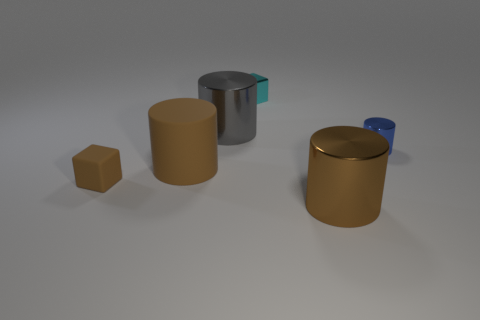Are there any other things that are the same material as the tiny brown thing?
Offer a very short reply. Yes. Does the large matte cylinder have the same color as the small block that is behind the gray cylinder?
Keep it short and to the point. No. There is a big metallic object in front of the cube in front of the blue metal cylinder; is there a small brown thing in front of it?
Keep it short and to the point. No. Is the number of big rubber cylinders that are behind the gray cylinder less than the number of tiny cyan cubes?
Keep it short and to the point. Yes. How many other objects are there of the same shape as the large brown metallic object?
Your answer should be very brief. 3. What number of objects are either matte objects to the right of the tiny brown block or small objects in front of the large gray metal cylinder?
Your answer should be compact. 3. There is a brown object that is both to the left of the small cyan block and on the right side of the brown rubber block; what size is it?
Your answer should be very brief. Large. Do the brown rubber object to the right of the small rubber cube and the brown metallic object have the same shape?
Give a very brief answer. Yes. What is the size of the cube that is left of the large brown cylinder behind the large cylinder in front of the brown rubber block?
Keep it short and to the point. Small. The metal thing that is the same color as the big matte thing is what size?
Make the answer very short. Large. 